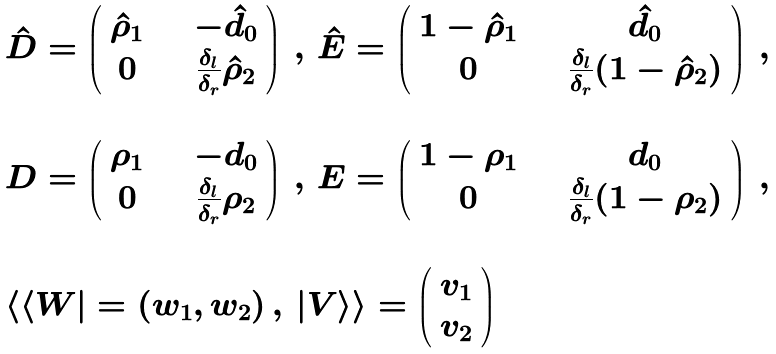Convert formula to latex. <formula><loc_0><loc_0><loc_500><loc_500>\begin{array} { l } \hat { D } = \left ( \begin{array} { c c c c } \hat { \rho } _ { 1 } & & & - \hat { d } _ { 0 } \\ 0 & & & \frac { \delta _ { l } } { \delta _ { r } } \hat { \rho } _ { 2 } \end{array} \right ) \, , \, \hat { E } = \left ( \begin{array} { c c c c } 1 - \hat { \rho } _ { 1 } & & & \hat { d } _ { 0 } \\ 0 & & & \frac { \delta _ { l } } { \delta _ { r } } ( 1 - \hat { \rho } _ { 2 } ) \end{array} \right ) \, , \, \\ \\ D = \left ( \begin{array} { c c c c } \rho _ { 1 } & & & - d _ { 0 } \\ 0 & & & \frac { \delta _ { l } } { \delta _ { r } } \rho _ { 2 } \end{array} \right ) \, , \, E = \left ( \begin{array} { c c c c } 1 - \rho _ { 1 } & & & d _ { 0 } \\ 0 & & & \frac { \delta _ { l } } { \delta _ { r } } ( 1 - \rho _ { 2 } ) \end{array} \right ) \, , \, \\ \\ \langle \langle W | = ( w _ { 1 } , w _ { 2 } ) \, , \, | V \rangle \rangle = \left ( \begin{array} { c } v _ { 1 } \\ v _ { 2 } \end{array} \right ) \end{array}</formula> 